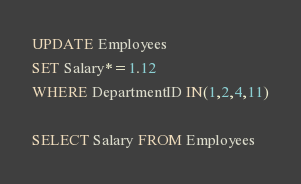Convert code to text. <code><loc_0><loc_0><loc_500><loc_500><_SQL_>UPDATE Employees
SET Salary*=1.12
WHERE DepartmentID IN(1,2,4,11)

SELECT Salary FROM Employees
</code> 